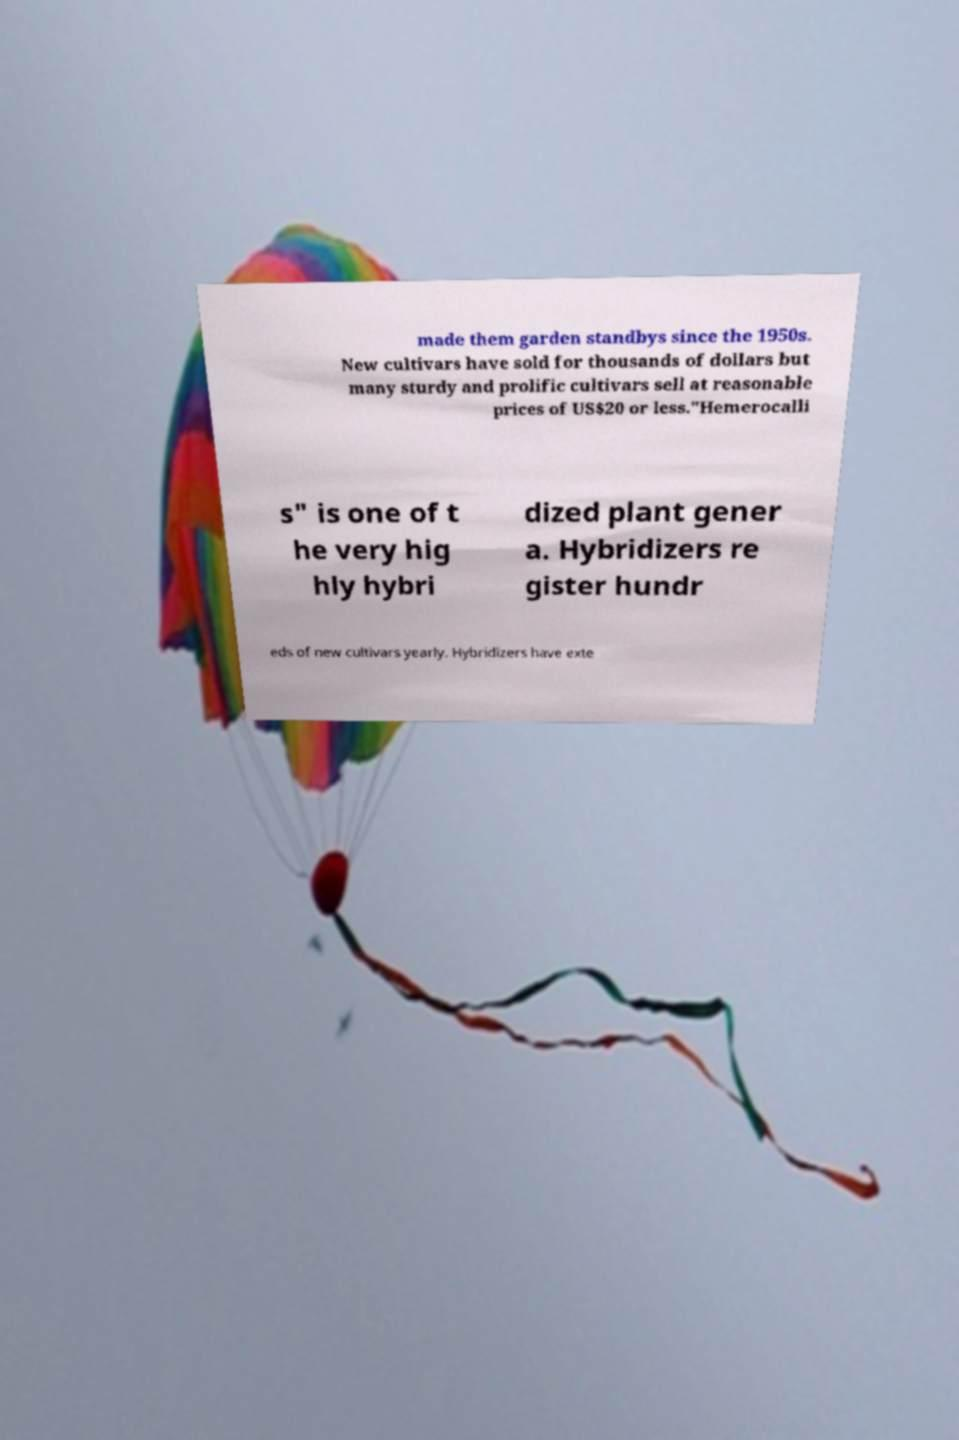Could you assist in decoding the text presented in this image and type it out clearly? made them garden standbys since the 1950s. New cultivars have sold for thousands of dollars but many sturdy and prolific cultivars sell at reasonable prices of US$20 or less."Hemerocalli s" is one of t he very hig hly hybri dized plant gener a. Hybridizers re gister hundr eds of new cultivars yearly. Hybridizers have exte 